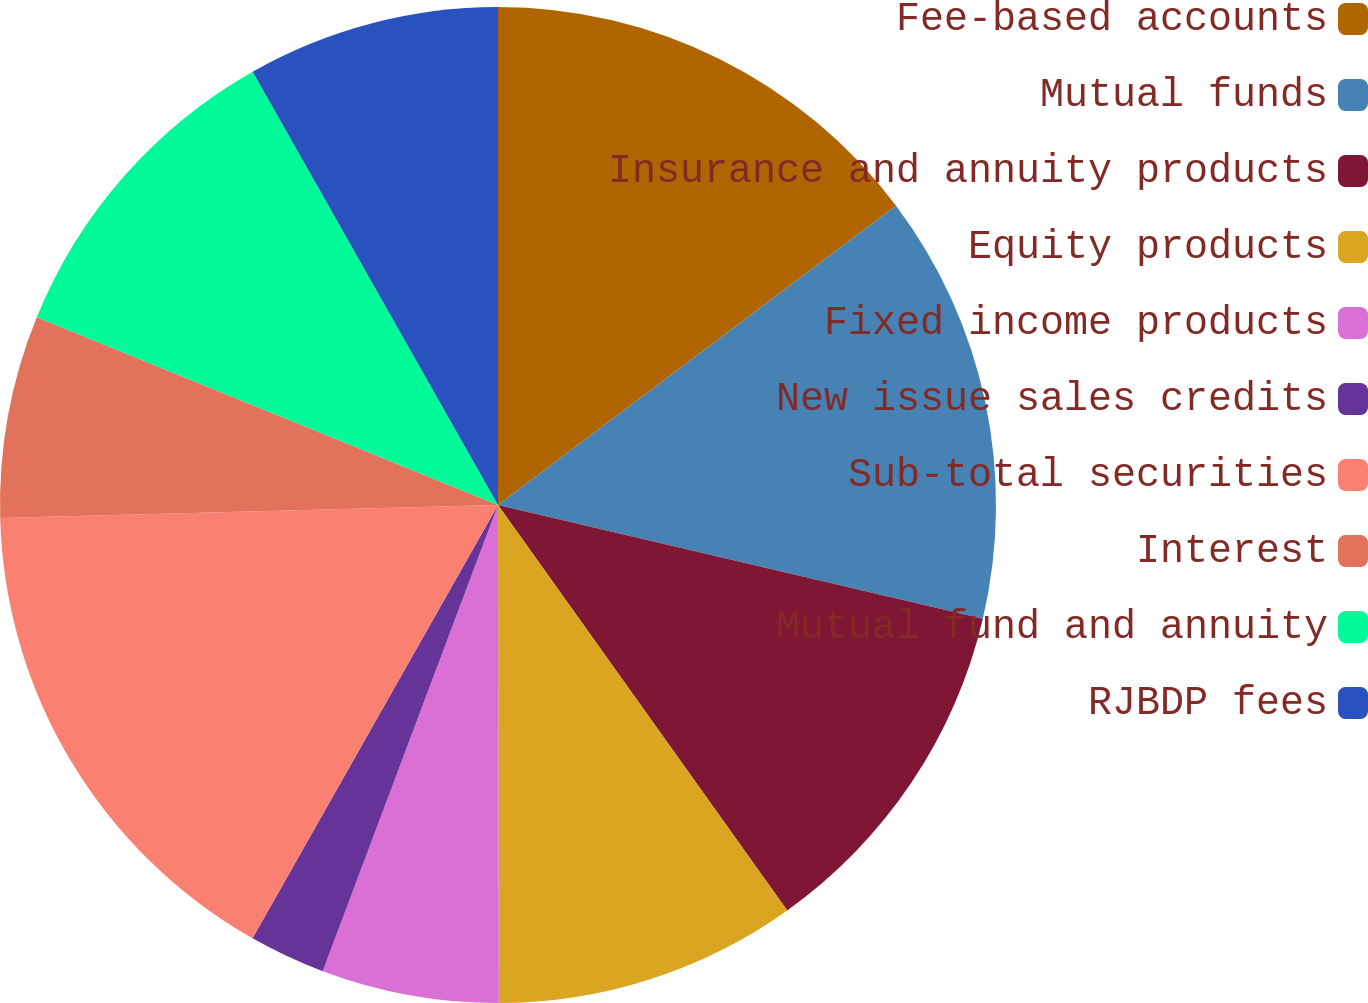<chart> <loc_0><loc_0><loc_500><loc_500><pie_chart><fcel>Fee-based accounts<fcel>Mutual funds<fcel>Insurance and annuity products<fcel>Equity products<fcel>Fixed income products<fcel>New issue sales credits<fcel>Sub-total securities<fcel>Interest<fcel>Mutual fund and annuity<fcel>RJBDP fees<nl><fcel>14.74%<fcel>13.93%<fcel>11.47%<fcel>9.84%<fcel>5.75%<fcel>2.48%<fcel>16.38%<fcel>6.57%<fcel>10.65%<fcel>8.2%<nl></chart> 